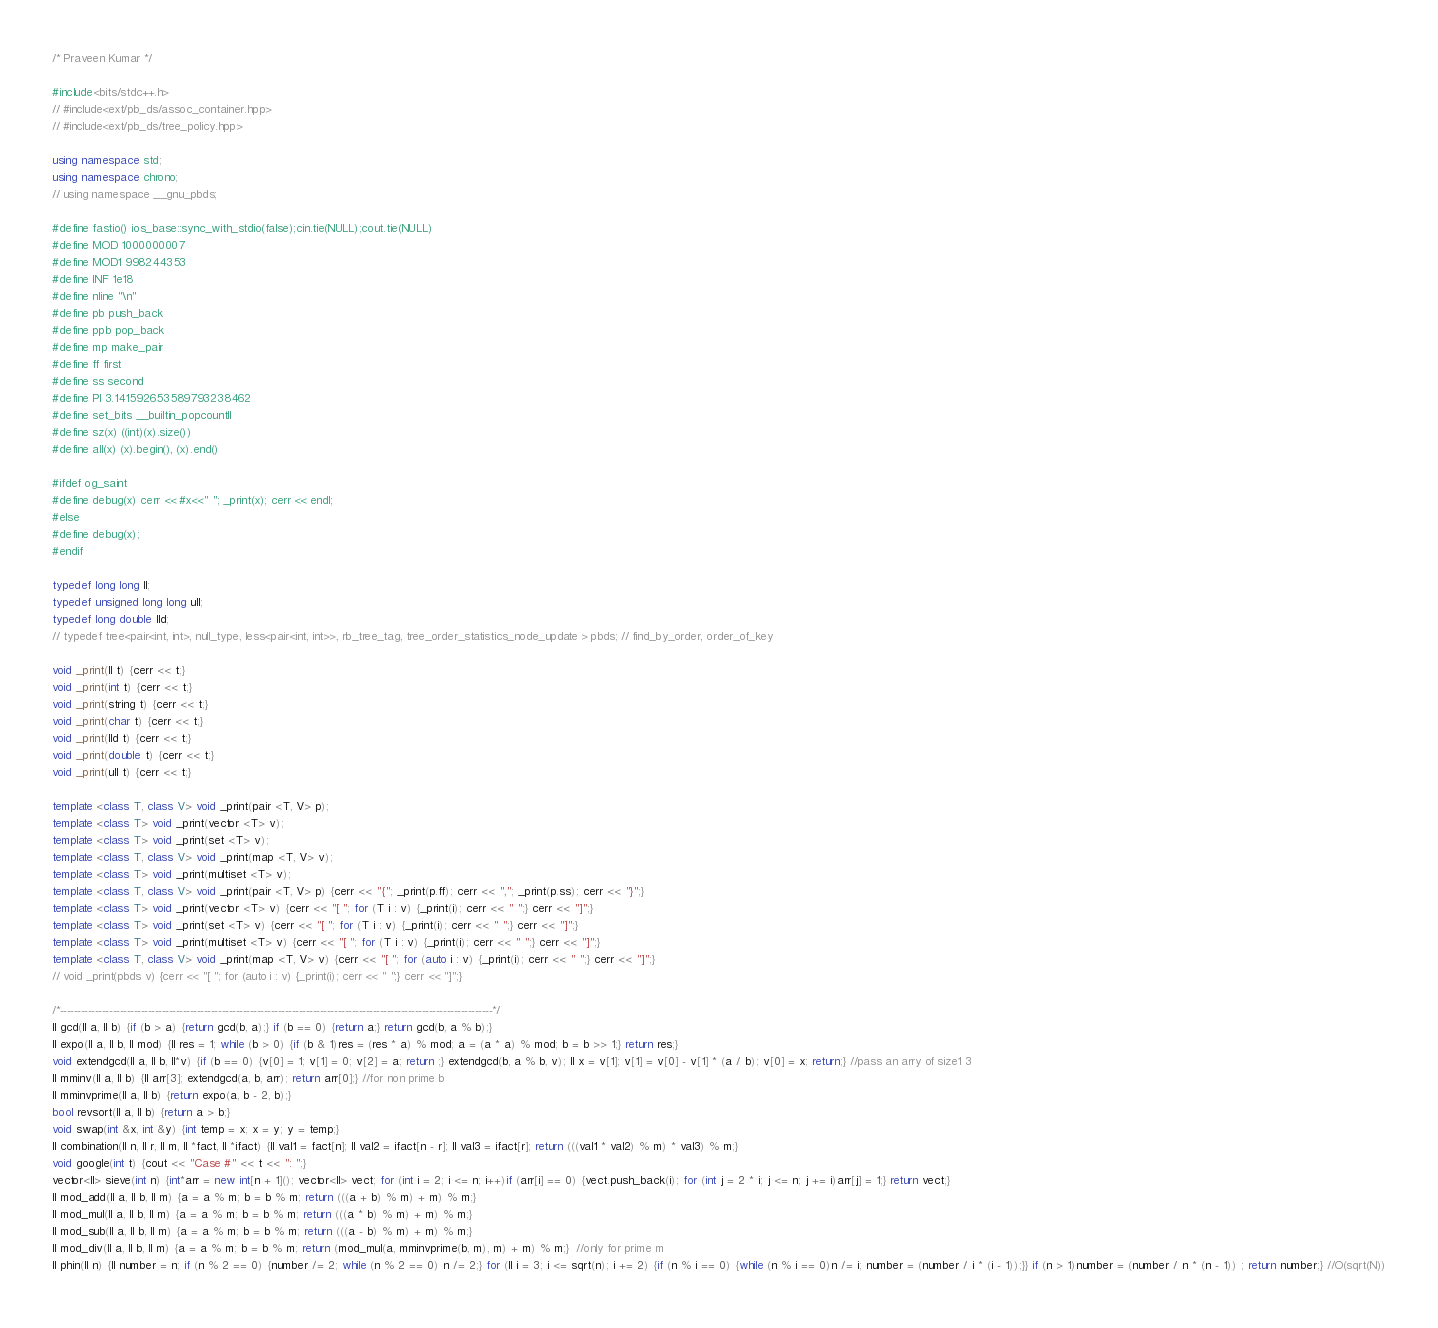<code> <loc_0><loc_0><loc_500><loc_500><_C++_>/* Praveen Kumar */

#include<bits/stdc++.h>
// #include<ext/pb_ds/assoc_container.hpp>
// #include<ext/pb_ds/tree_policy.hpp>

using namespace std;
using namespace chrono;
// using namespace __gnu_pbds;

#define fastio() ios_base::sync_with_stdio(false);cin.tie(NULL);cout.tie(NULL)
#define MOD 1000000007
#define MOD1 998244353
#define INF 1e18
#define nline "\n"
#define pb push_back
#define ppb pop_back
#define mp make_pair
#define ff first
#define ss second
#define PI 3.141592653589793238462
#define set_bits __builtin_popcountll
#define sz(x) ((int)(x).size())
#define all(x) (x).begin(), (x).end()

#ifdef og_saint
#define debug(x) cerr << #x<<" "; _print(x); cerr << endl;
#else
#define debug(x);
#endif

typedef long long ll;
typedef unsigned long long ull;
typedef long double lld;
// typedef tree<pair<int, int>, null_type, less<pair<int, int>>, rb_tree_tag, tree_order_statistics_node_update > pbds; // find_by_order, order_of_key

void _print(ll t) {cerr << t;}
void _print(int t) {cerr << t;}
void _print(string t) {cerr << t;}
void _print(char t) {cerr << t;}
void _print(lld t) {cerr << t;}
void _print(double t) {cerr << t;}
void _print(ull t) {cerr << t;}

template <class T, class V> void _print(pair <T, V> p);
template <class T> void _print(vector <T> v);
template <class T> void _print(set <T> v);
template <class T, class V> void _print(map <T, V> v);
template <class T> void _print(multiset <T> v);
template <class T, class V> void _print(pair <T, V> p) {cerr << "{"; _print(p.ff); cerr << ","; _print(p.ss); cerr << "}";}
template <class T> void _print(vector <T> v) {cerr << "[ "; for (T i : v) {_print(i); cerr << " ";} cerr << "]";}
template <class T> void _print(set <T> v) {cerr << "[ "; for (T i : v) {_print(i); cerr << " ";} cerr << "]";}
template <class T> void _print(multiset <T> v) {cerr << "[ "; for (T i : v) {_print(i); cerr << " ";} cerr << "]";}
template <class T, class V> void _print(map <T, V> v) {cerr << "[ "; for (auto i : v) {_print(i); cerr << " ";} cerr << "]";}
// void _print(pbds v) {cerr << "[ "; for (auto i : v) {_print(i); cerr << " ";} cerr << "]";}

/*---------------------------------------------------------------------------------------------------------------------------*/
ll gcd(ll a, ll b) {if (b > a) {return gcd(b, a);} if (b == 0) {return a;} return gcd(b, a % b);}
ll expo(ll a, ll b, ll mod) {ll res = 1; while (b > 0) {if (b & 1)res = (res * a) % mod; a = (a * a) % mod; b = b >> 1;} return res;}
void extendgcd(ll a, ll b, ll*v) {if (b == 0) {v[0] = 1; v[1] = 0; v[2] = a; return ;} extendgcd(b, a % b, v); ll x = v[1]; v[1] = v[0] - v[1] * (a / b); v[0] = x; return;} //pass an arry of size1 3
ll mminv(ll a, ll b) {ll arr[3]; extendgcd(a, b, arr); return arr[0];} //for non prime b
ll mminvprime(ll a, ll b) {return expo(a, b - 2, b);}
bool revsort(ll a, ll b) {return a > b;}
void swap(int &x, int &y) {int temp = x; x = y; y = temp;}
ll combination(ll n, ll r, ll m, ll *fact, ll *ifact) {ll val1 = fact[n]; ll val2 = ifact[n - r]; ll val3 = ifact[r]; return (((val1 * val2) % m) * val3) % m;}
void google(int t) {cout << "Case #" << t << ": ";}
vector<ll> sieve(int n) {int*arr = new int[n + 1](); vector<ll> vect; for (int i = 2; i <= n; i++)if (arr[i] == 0) {vect.push_back(i); for (int j = 2 * i; j <= n; j += i)arr[j] = 1;} return vect;}
ll mod_add(ll a, ll b, ll m) {a = a % m; b = b % m; return (((a + b) % m) + m) % m;}
ll mod_mul(ll a, ll b, ll m) {a = a % m; b = b % m; return (((a * b) % m) + m) % m;}
ll mod_sub(ll a, ll b, ll m) {a = a % m; b = b % m; return (((a - b) % m) + m) % m;}
ll mod_div(ll a, ll b, ll m) {a = a % m; b = b % m; return (mod_mul(a, mminvprime(b, m), m) + m) % m;}  //only for prime m
ll phin(ll n) {ll number = n; if (n % 2 == 0) {number /= 2; while (n % 2 == 0) n /= 2;} for (ll i = 3; i <= sqrt(n); i += 2) {if (n % i == 0) {while (n % i == 0)n /= i; number = (number / i * (i - 1));}} if (n > 1)number = (number / n * (n - 1)) ; return number;} //O(sqrt(N))</code> 